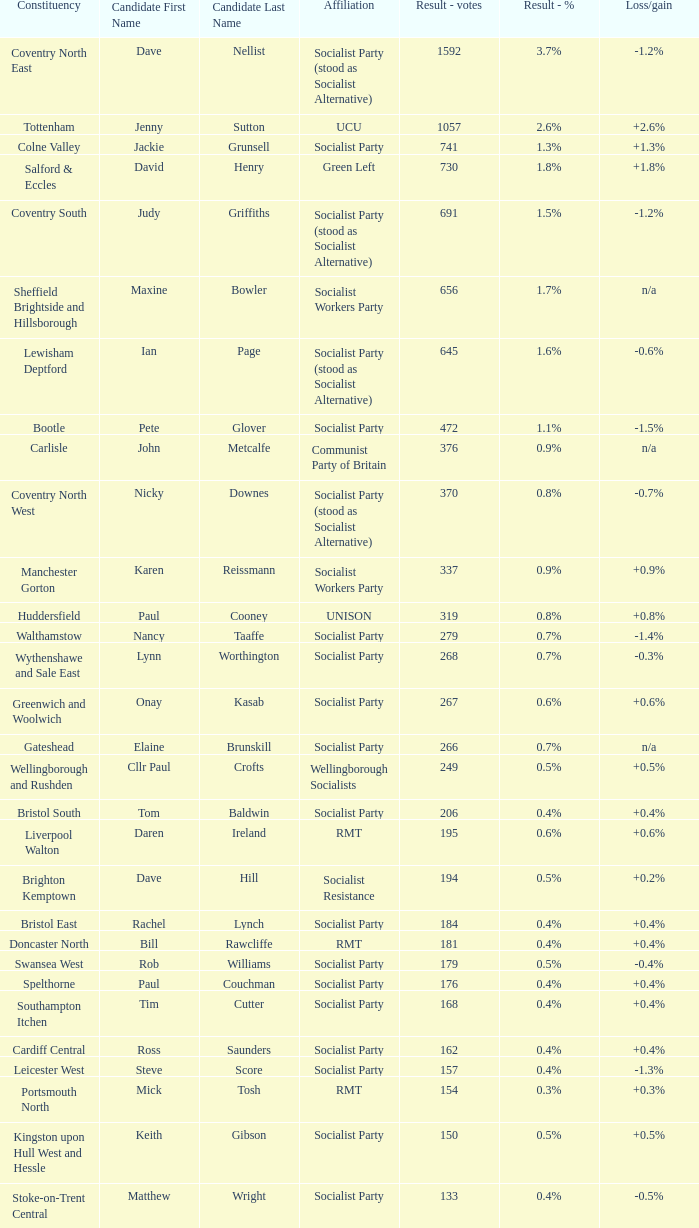What is the largest vote result for the Huddersfield constituency? 319.0. 